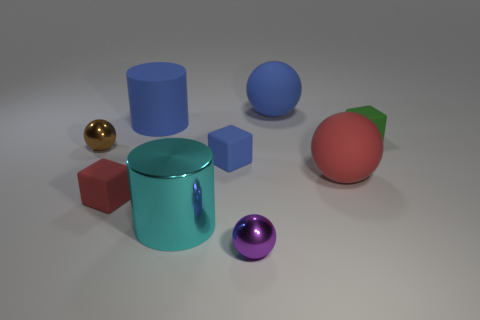How many other objects are there of the same size as the cyan cylinder?
Provide a succinct answer. 3. What is the material of the small blue thing?
Make the answer very short. Rubber. Is the number of large matte balls that are in front of the tiny blue block greater than the number of tiny rubber balls?
Your response must be concise. Yes. Is there a tiny metal cube?
Make the answer very short. No. How many other objects are there of the same shape as the large red thing?
Your answer should be compact. 3. Do the large matte object to the left of the purple ball and the big matte sphere that is behind the small brown shiny thing have the same color?
Offer a terse response. Yes. There is a purple sphere on the right side of the tiny shiny object to the left of the big cylinder that is behind the small green object; how big is it?
Provide a succinct answer. Small. The tiny thing that is behind the small purple thing and in front of the small blue cube has what shape?
Offer a terse response. Cube. Is the number of small blocks that are to the right of the blue cube the same as the number of matte spheres behind the tiny brown metal sphere?
Your response must be concise. Yes. Is there another object that has the same material as the purple thing?
Your answer should be very brief. Yes. 